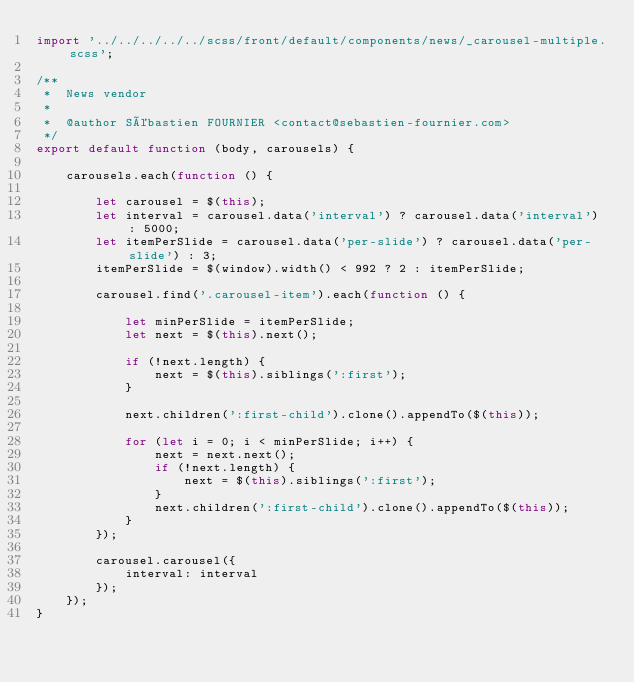<code> <loc_0><loc_0><loc_500><loc_500><_JavaScript_>import '../../../../../scss/front/default/components/news/_carousel-multiple.scss';

/**
 *  News vendor
 *
 *  @author Sébastien FOURNIER <contact@sebastien-fournier.com>
 */
export default function (body, carousels) {

    carousels.each(function () {

        let carousel = $(this);
        let interval = carousel.data('interval') ? carousel.data('interval') : 5000;
        let itemPerSlide = carousel.data('per-slide') ? carousel.data('per-slide') : 3;
        itemPerSlide = $(window).width() < 992 ? 2 : itemPerSlide;

        carousel.find('.carousel-item').each(function () {

            let minPerSlide = itemPerSlide;
            let next = $(this).next();

            if (!next.length) {
                next = $(this).siblings(':first');
            }

            next.children(':first-child').clone().appendTo($(this));

            for (let i = 0; i < minPerSlide; i++) {
                next = next.next();
                if (!next.length) {
                    next = $(this).siblings(':first');
                }
                next.children(':first-child').clone().appendTo($(this));
            }
        });

        carousel.carousel({
            interval: interval
        });
    });
}</code> 